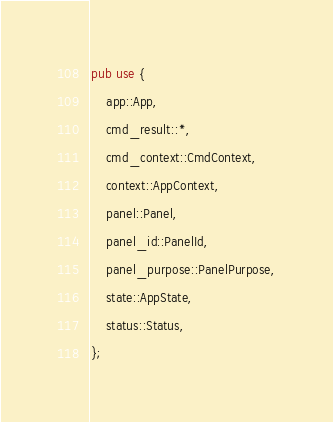<code> <loc_0><loc_0><loc_500><loc_500><_Rust_>
pub use {
    app::App,
    cmd_result::*,
    cmd_context::CmdContext,
    context::AppContext,
    panel::Panel,
    panel_id::PanelId,
    panel_purpose::PanelPurpose,
    state::AppState,
    status::Status,
};
</code> 